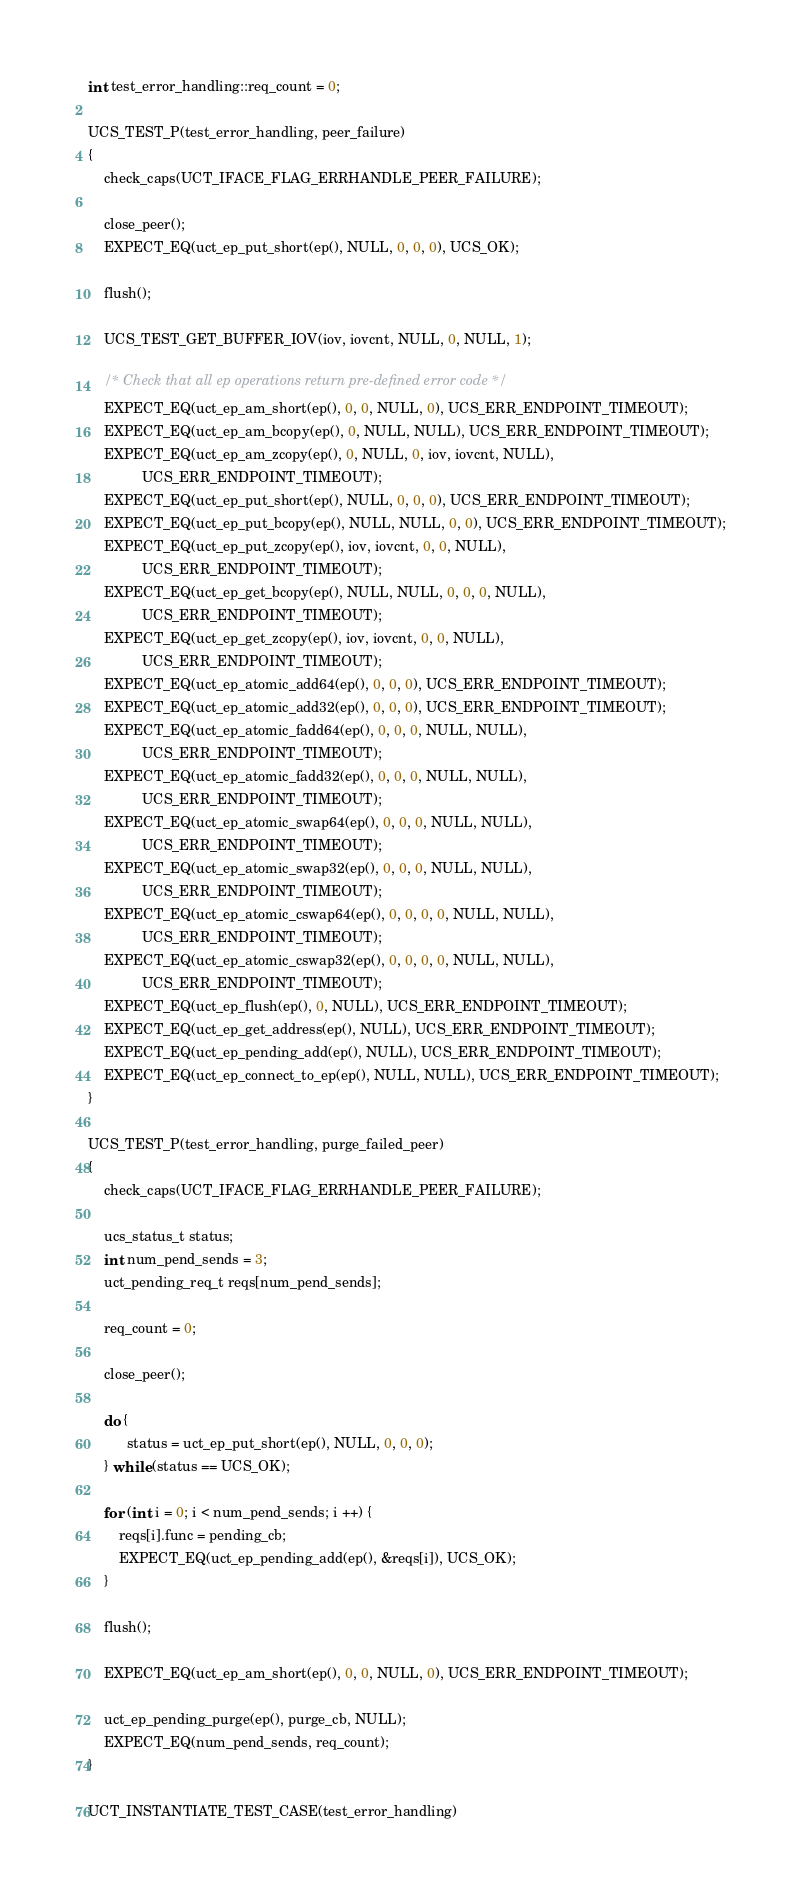Convert code to text. <code><loc_0><loc_0><loc_500><loc_500><_C++_>int test_error_handling::req_count = 0;

UCS_TEST_P(test_error_handling, peer_failure)
{
    check_caps(UCT_IFACE_FLAG_ERRHANDLE_PEER_FAILURE);

    close_peer();
    EXPECT_EQ(uct_ep_put_short(ep(), NULL, 0, 0, 0), UCS_OK);

    flush();

    UCS_TEST_GET_BUFFER_IOV(iov, iovcnt, NULL, 0, NULL, 1);

    /* Check that all ep operations return pre-defined error code */
    EXPECT_EQ(uct_ep_am_short(ep(), 0, 0, NULL, 0), UCS_ERR_ENDPOINT_TIMEOUT);
    EXPECT_EQ(uct_ep_am_bcopy(ep(), 0, NULL, NULL), UCS_ERR_ENDPOINT_TIMEOUT);
    EXPECT_EQ(uct_ep_am_zcopy(ep(), 0, NULL, 0, iov, iovcnt, NULL),
              UCS_ERR_ENDPOINT_TIMEOUT);
    EXPECT_EQ(uct_ep_put_short(ep(), NULL, 0, 0, 0), UCS_ERR_ENDPOINT_TIMEOUT);
    EXPECT_EQ(uct_ep_put_bcopy(ep(), NULL, NULL, 0, 0), UCS_ERR_ENDPOINT_TIMEOUT);
    EXPECT_EQ(uct_ep_put_zcopy(ep(), iov, iovcnt, 0, 0, NULL),
              UCS_ERR_ENDPOINT_TIMEOUT);
    EXPECT_EQ(uct_ep_get_bcopy(ep(), NULL, NULL, 0, 0, 0, NULL),
              UCS_ERR_ENDPOINT_TIMEOUT);
    EXPECT_EQ(uct_ep_get_zcopy(ep(), iov, iovcnt, 0, 0, NULL),
              UCS_ERR_ENDPOINT_TIMEOUT);
    EXPECT_EQ(uct_ep_atomic_add64(ep(), 0, 0, 0), UCS_ERR_ENDPOINT_TIMEOUT);
    EXPECT_EQ(uct_ep_atomic_add32(ep(), 0, 0, 0), UCS_ERR_ENDPOINT_TIMEOUT);
    EXPECT_EQ(uct_ep_atomic_fadd64(ep(), 0, 0, 0, NULL, NULL),
              UCS_ERR_ENDPOINT_TIMEOUT);
    EXPECT_EQ(uct_ep_atomic_fadd32(ep(), 0, 0, 0, NULL, NULL),
              UCS_ERR_ENDPOINT_TIMEOUT);
    EXPECT_EQ(uct_ep_atomic_swap64(ep(), 0, 0, 0, NULL, NULL),
              UCS_ERR_ENDPOINT_TIMEOUT);
    EXPECT_EQ(uct_ep_atomic_swap32(ep(), 0, 0, 0, NULL, NULL),
              UCS_ERR_ENDPOINT_TIMEOUT);
    EXPECT_EQ(uct_ep_atomic_cswap64(ep(), 0, 0, 0, 0, NULL, NULL),
              UCS_ERR_ENDPOINT_TIMEOUT);
    EXPECT_EQ(uct_ep_atomic_cswap32(ep(), 0, 0, 0, 0, NULL, NULL),
              UCS_ERR_ENDPOINT_TIMEOUT);
    EXPECT_EQ(uct_ep_flush(ep(), 0, NULL), UCS_ERR_ENDPOINT_TIMEOUT);
    EXPECT_EQ(uct_ep_get_address(ep(), NULL), UCS_ERR_ENDPOINT_TIMEOUT);
    EXPECT_EQ(uct_ep_pending_add(ep(), NULL), UCS_ERR_ENDPOINT_TIMEOUT);
    EXPECT_EQ(uct_ep_connect_to_ep(ep(), NULL, NULL), UCS_ERR_ENDPOINT_TIMEOUT);
}

UCS_TEST_P(test_error_handling, purge_failed_peer)
{
    check_caps(UCT_IFACE_FLAG_ERRHANDLE_PEER_FAILURE);

    ucs_status_t status;
    int num_pend_sends = 3;
    uct_pending_req_t reqs[num_pend_sends];

    req_count = 0;

    close_peer();

    do {
          status = uct_ep_put_short(ep(), NULL, 0, 0, 0);
    } while (status == UCS_OK);

    for (int i = 0; i < num_pend_sends; i ++) {
        reqs[i].func = pending_cb;
        EXPECT_EQ(uct_ep_pending_add(ep(), &reqs[i]), UCS_OK);
    }

    flush();

    EXPECT_EQ(uct_ep_am_short(ep(), 0, 0, NULL, 0), UCS_ERR_ENDPOINT_TIMEOUT);

    uct_ep_pending_purge(ep(), purge_cb, NULL);
    EXPECT_EQ(num_pend_sends, req_count);
}

UCT_INSTANTIATE_TEST_CASE(test_error_handling)
</code> 